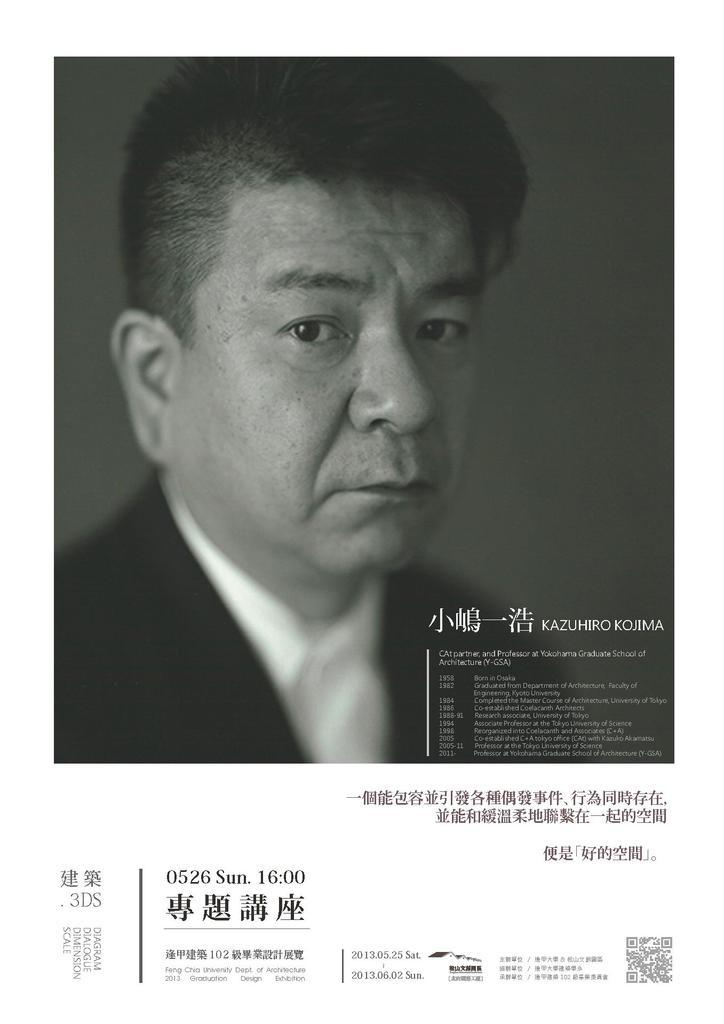What is the main subject of the picture? The main subject of the picture is a man standing. What is the man wearing in the picture? The man is wearing a black blazer and a white shirt. Is there any text present in the picture? Yes, there is text written on the picture. What advice does the stranger in the picture give to the man? There is no stranger present in the picture, and therefore no advice can be given or received. What type of tax is mentioned in the text written on the picture? There is no mention of tax in the text written on the picture. 